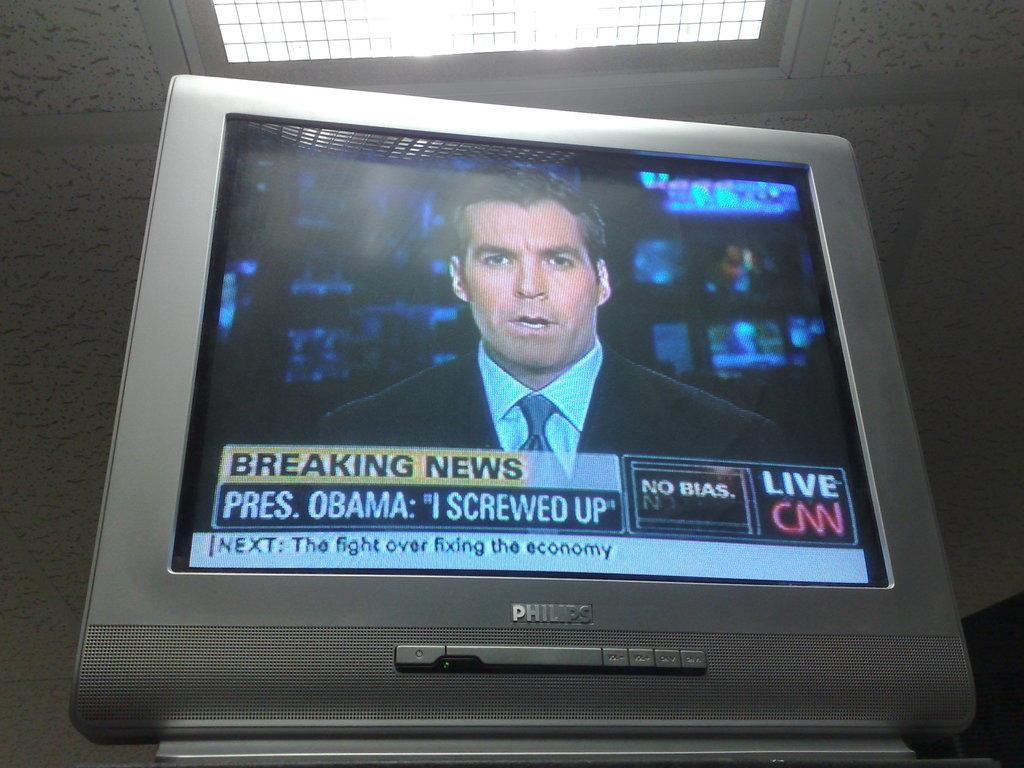<image>
Provide a brief description of the given image. A TV monitor to a breaking news story about Obama on CNN featuring an anchor man 